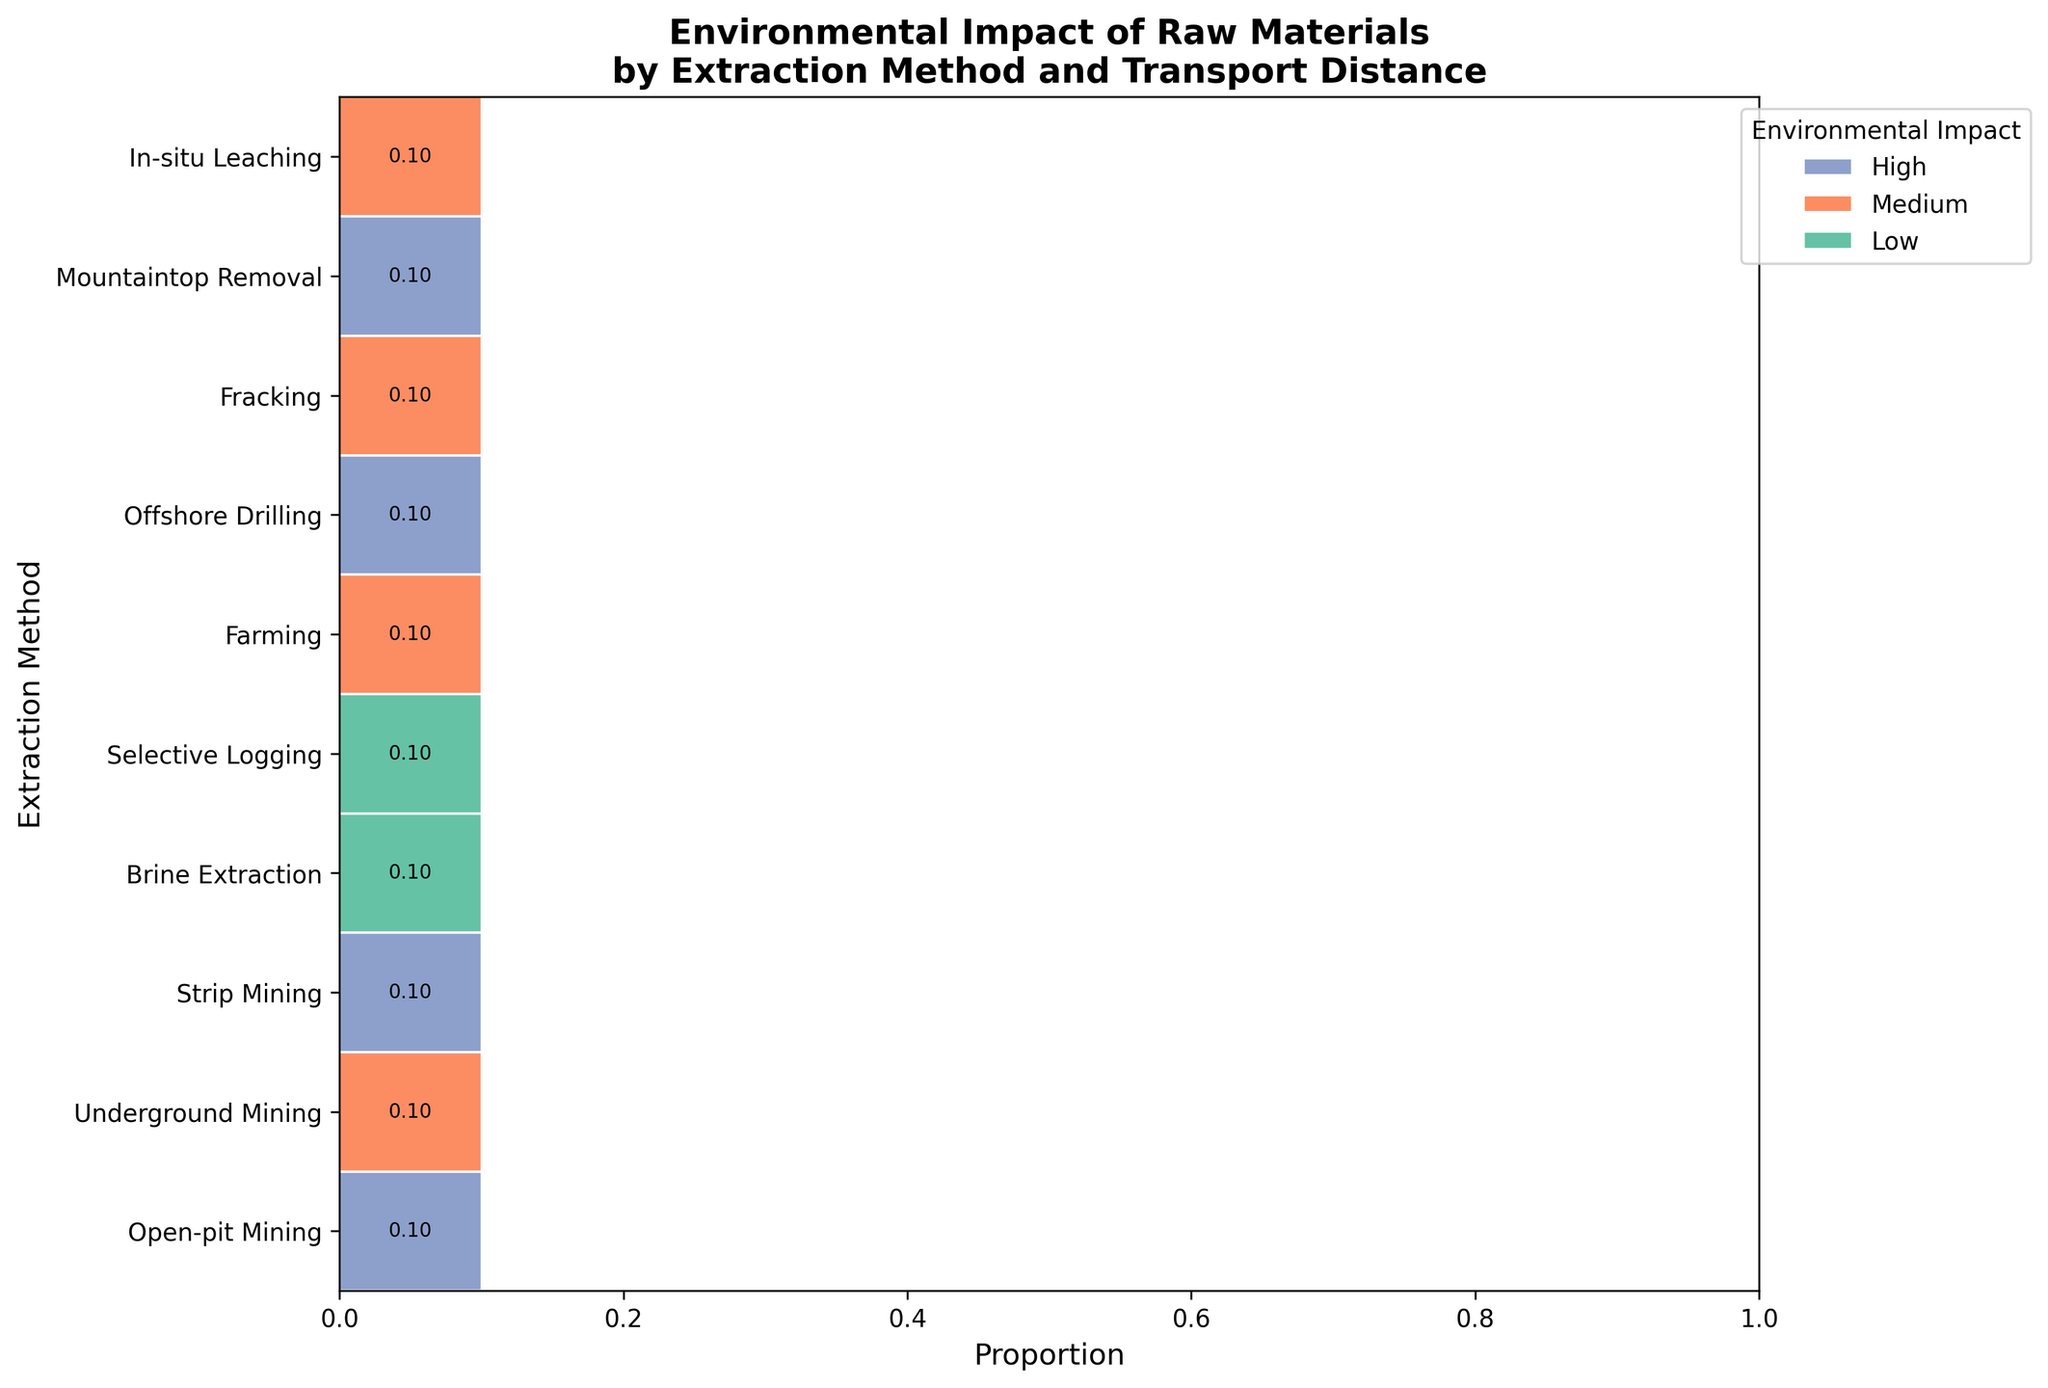What's the title of the figure? The title is located at the top of the plot. It provides a summary of what the plot represents.
Answer: Environmental Impact of Raw Materials by Extraction Method and Transport Distance Which extraction method has the highest proportion of high environmental impact? To determine this, look for the color associated with high impact (purple) and identify the extraction method with the largest block of this color.
Answer: Open-pit Mining What proportion of raw materials with brine extraction and short transport distance have a low environmental impact? Find the bar corresponding to "Brine Extraction" and check the segment with the label "Short (<1000km)" and color representing low impact (green). Identify the proportion value indicated in this segment.
Answer: 0.10 How many raw materials are involved in underground mining? Count the number of color segments in the row associated with "Underground Mining". Each segment corresponds to a unique raw material type.
Answer: 1 What is the common environmental impact for materials transported over long distances? Examine the color segments in the column labeled "Long (>5000km)" and identify the most frequent color and associated label.
Answer: High Compare the environmental impact of selective logging and mountaintop removal mining. Which has a higher proportion of materials with medium impact? Identify the segments for "Selective Logging" and "Mountaintop Removal Mining" and compare the proportions of medium impact (orange) in both.
Answer: Selective Logging Which transport distance category contributes the most to high environmental impact within open-pit mining? Find the "Open-pit Mining" row, identify the high impact (purple) segments, and compare their proportions across different transport distances.
Answer: Long (>5000km) What proportion of materials using offshore drilling have a medium to high environmental impact? Locate the row for "Offshore Drilling" and sum the proportions of medium (orange) and high (purple) impact segments. Add the proportion values shown.
Answer: 0.20 How does the environmental impact of brine extraction compare with in-situ leaching? Compare the color segments for "Brine Extraction" and "In-situ Leaching" across different impact categories, noting the proportions represented.
Answer: Brine Extraction has a lower average impact What proportion of raw materials are transported over medium distances? Add the proportions of all segments with the label "Medium (1000-5000km)" across all extraction methods. Sum these values to find the total proportion.
Answer: 0.30 